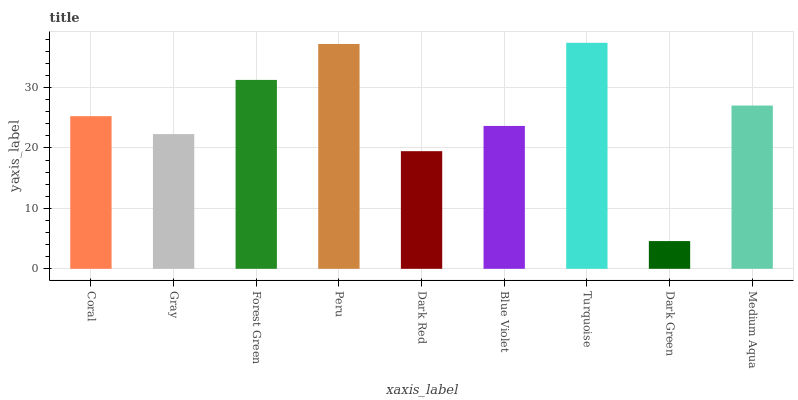Is Dark Green the minimum?
Answer yes or no. Yes. Is Turquoise the maximum?
Answer yes or no. Yes. Is Gray the minimum?
Answer yes or no. No. Is Gray the maximum?
Answer yes or no. No. Is Coral greater than Gray?
Answer yes or no. Yes. Is Gray less than Coral?
Answer yes or no. Yes. Is Gray greater than Coral?
Answer yes or no. No. Is Coral less than Gray?
Answer yes or no. No. Is Coral the high median?
Answer yes or no. Yes. Is Coral the low median?
Answer yes or no. Yes. Is Forest Green the high median?
Answer yes or no. No. Is Dark Red the low median?
Answer yes or no. No. 